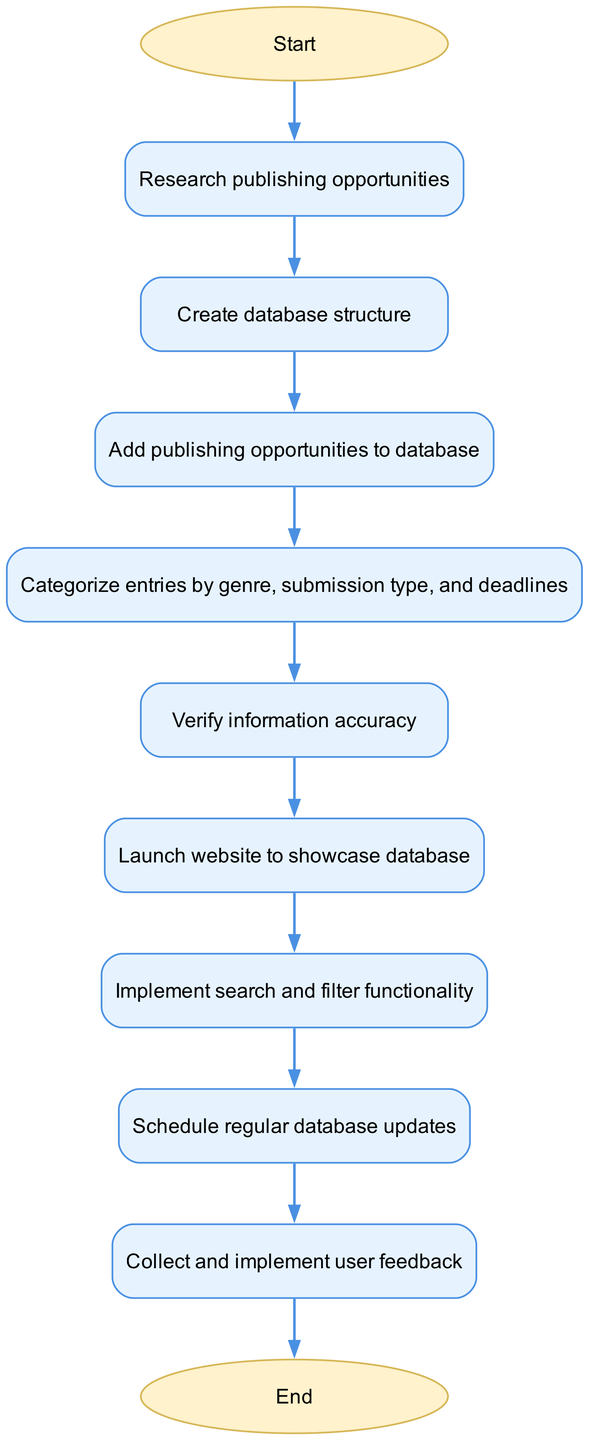What is the first step in this flowchart? The flowchart begins with the node labeled "Start," which indicates the initiation of the process. This is the first step in the diagram.
Answer: Start How many nodes are in this flowchart? The total number of nodes is determined by counting all the distinct steps in the flowchart. There are eleven nodes including the start and end nodes.
Answer: Eleven What step follows "Verify information accuracy"? In the flowchart, the step that directly follows "Verify information accuracy" is "Launch website to showcase database." This shows the progression after verification.
Answer: Launch website to showcase database If the website is launched, what is the next step that should be performed? After the "Launch website to showcase database," the next step to be performed is "Implement search and filter functionality." This is the step that comes immediately after launching the website as per the diagram flow.
Answer: Implement search and filter functionality Which node represents the step to collect feedback from users? The step that involves gathering opinions or suggestions from users is represented by the node titled "Collect and implement user feedback." This specifies the action taken post-update of the database.
Answer: Collect and implement user feedback What relationship exists between "Add publishing opportunities to database" and "Categorize entries by genre, submission type, and deadlines"? The relationship is sequential; "Add publishing opportunities to database" directly leads into "Categorize entries by genre, submission type, and deadlines," indicating that categorization occurs after adding entries to the database.
Answer: Sequential relationship What step comes before "Regular database updates"? Before "Regular database updates," the preceding step is "Implement search and filter functionality." This indicates the activities that should occur prior to scheduling updates.
Answer: Implement search and filter functionality How does the flowchart end? The flowchart concludes with the node labeled "End," which signifies the final point of the process after all steps have been completed.
Answer: End 